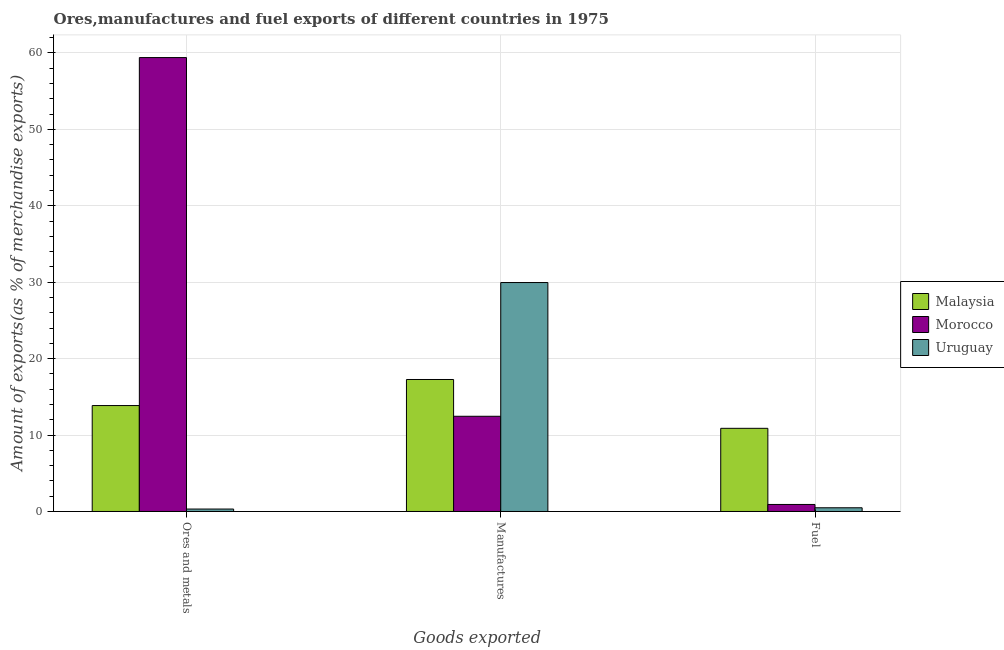How many different coloured bars are there?
Give a very brief answer. 3. How many groups of bars are there?
Keep it short and to the point. 3. Are the number of bars on each tick of the X-axis equal?
Keep it short and to the point. Yes. How many bars are there on the 1st tick from the right?
Provide a short and direct response. 3. What is the label of the 1st group of bars from the left?
Make the answer very short. Ores and metals. What is the percentage of manufactures exports in Morocco?
Your answer should be compact. 12.46. Across all countries, what is the maximum percentage of ores and metals exports?
Offer a terse response. 59.39. Across all countries, what is the minimum percentage of fuel exports?
Provide a short and direct response. 0.49. In which country was the percentage of ores and metals exports maximum?
Ensure brevity in your answer.  Morocco. In which country was the percentage of fuel exports minimum?
Offer a very short reply. Uruguay. What is the total percentage of manufactures exports in the graph?
Make the answer very short. 59.69. What is the difference between the percentage of ores and metals exports in Malaysia and that in Uruguay?
Keep it short and to the point. 13.54. What is the difference between the percentage of ores and metals exports in Malaysia and the percentage of manufactures exports in Uruguay?
Keep it short and to the point. -16.1. What is the average percentage of ores and metals exports per country?
Make the answer very short. 24.52. What is the difference between the percentage of fuel exports and percentage of manufactures exports in Uruguay?
Give a very brief answer. -29.47. In how many countries, is the percentage of fuel exports greater than 44 %?
Your response must be concise. 0. What is the ratio of the percentage of manufactures exports in Malaysia to that in Morocco?
Offer a terse response. 1.39. Is the difference between the percentage of fuel exports in Uruguay and Morocco greater than the difference between the percentage of manufactures exports in Uruguay and Morocco?
Your answer should be compact. No. What is the difference between the highest and the second highest percentage of manufactures exports?
Your answer should be very brief. 12.69. What is the difference between the highest and the lowest percentage of ores and metals exports?
Your answer should be very brief. 59.07. Is the sum of the percentage of ores and metals exports in Malaysia and Uruguay greater than the maximum percentage of fuel exports across all countries?
Your answer should be compact. Yes. What does the 2nd bar from the left in Ores and metals represents?
Make the answer very short. Morocco. What does the 1st bar from the right in Manufactures represents?
Offer a terse response. Uruguay. Is it the case that in every country, the sum of the percentage of ores and metals exports and percentage of manufactures exports is greater than the percentage of fuel exports?
Your answer should be very brief. Yes. Are all the bars in the graph horizontal?
Your answer should be very brief. No. Are the values on the major ticks of Y-axis written in scientific E-notation?
Your response must be concise. No. Does the graph contain grids?
Your response must be concise. Yes. How are the legend labels stacked?
Offer a very short reply. Vertical. What is the title of the graph?
Offer a terse response. Ores,manufactures and fuel exports of different countries in 1975. What is the label or title of the X-axis?
Provide a succinct answer. Goods exported. What is the label or title of the Y-axis?
Keep it short and to the point. Amount of exports(as % of merchandise exports). What is the Amount of exports(as % of merchandise exports) in Malaysia in Ores and metals?
Your answer should be very brief. 13.86. What is the Amount of exports(as % of merchandise exports) in Morocco in Ores and metals?
Your answer should be compact. 59.39. What is the Amount of exports(as % of merchandise exports) of Uruguay in Ores and metals?
Offer a terse response. 0.32. What is the Amount of exports(as % of merchandise exports) in Malaysia in Manufactures?
Make the answer very short. 17.27. What is the Amount of exports(as % of merchandise exports) in Morocco in Manufactures?
Offer a terse response. 12.46. What is the Amount of exports(as % of merchandise exports) in Uruguay in Manufactures?
Provide a succinct answer. 29.96. What is the Amount of exports(as % of merchandise exports) of Malaysia in Fuel?
Offer a terse response. 10.88. What is the Amount of exports(as % of merchandise exports) in Morocco in Fuel?
Provide a short and direct response. 0.92. What is the Amount of exports(as % of merchandise exports) of Uruguay in Fuel?
Offer a terse response. 0.49. Across all Goods exported, what is the maximum Amount of exports(as % of merchandise exports) of Malaysia?
Ensure brevity in your answer.  17.27. Across all Goods exported, what is the maximum Amount of exports(as % of merchandise exports) in Morocco?
Ensure brevity in your answer.  59.39. Across all Goods exported, what is the maximum Amount of exports(as % of merchandise exports) of Uruguay?
Offer a terse response. 29.96. Across all Goods exported, what is the minimum Amount of exports(as % of merchandise exports) of Malaysia?
Your response must be concise. 10.88. Across all Goods exported, what is the minimum Amount of exports(as % of merchandise exports) in Morocco?
Your answer should be compact. 0.92. Across all Goods exported, what is the minimum Amount of exports(as % of merchandise exports) of Uruguay?
Give a very brief answer. 0.32. What is the total Amount of exports(as % of merchandise exports) in Malaysia in the graph?
Ensure brevity in your answer.  42.01. What is the total Amount of exports(as % of merchandise exports) in Morocco in the graph?
Offer a very short reply. 72.77. What is the total Amount of exports(as % of merchandise exports) in Uruguay in the graph?
Make the answer very short. 30.76. What is the difference between the Amount of exports(as % of merchandise exports) of Malaysia in Ores and metals and that in Manufactures?
Provide a short and direct response. -3.41. What is the difference between the Amount of exports(as % of merchandise exports) in Morocco in Ores and metals and that in Manufactures?
Offer a terse response. 46.93. What is the difference between the Amount of exports(as % of merchandise exports) in Uruguay in Ores and metals and that in Manufactures?
Provide a short and direct response. -29.64. What is the difference between the Amount of exports(as % of merchandise exports) of Malaysia in Ores and metals and that in Fuel?
Make the answer very short. 2.98. What is the difference between the Amount of exports(as % of merchandise exports) in Morocco in Ores and metals and that in Fuel?
Your response must be concise. 58.47. What is the difference between the Amount of exports(as % of merchandise exports) of Uruguay in Ores and metals and that in Fuel?
Your answer should be compact. -0.17. What is the difference between the Amount of exports(as % of merchandise exports) in Malaysia in Manufactures and that in Fuel?
Provide a short and direct response. 6.39. What is the difference between the Amount of exports(as % of merchandise exports) in Morocco in Manufactures and that in Fuel?
Provide a short and direct response. 11.54. What is the difference between the Amount of exports(as % of merchandise exports) in Uruguay in Manufactures and that in Fuel?
Your answer should be compact. 29.47. What is the difference between the Amount of exports(as % of merchandise exports) in Malaysia in Ores and metals and the Amount of exports(as % of merchandise exports) in Morocco in Manufactures?
Provide a succinct answer. 1.4. What is the difference between the Amount of exports(as % of merchandise exports) of Malaysia in Ores and metals and the Amount of exports(as % of merchandise exports) of Uruguay in Manufactures?
Ensure brevity in your answer.  -16.1. What is the difference between the Amount of exports(as % of merchandise exports) of Morocco in Ores and metals and the Amount of exports(as % of merchandise exports) of Uruguay in Manufactures?
Provide a short and direct response. 29.44. What is the difference between the Amount of exports(as % of merchandise exports) of Malaysia in Ores and metals and the Amount of exports(as % of merchandise exports) of Morocco in Fuel?
Give a very brief answer. 12.94. What is the difference between the Amount of exports(as % of merchandise exports) in Malaysia in Ores and metals and the Amount of exports(as % of merchandise exports) in Uruguay in Fuel?
Make the answer very short. 13.37. What is the difference between the Amount of exports(as % of merchandise exports) in Morocco in Ores and metals and the Amount of exports(as % of merchandise exports) in Uruguay in Fuel?
Provide a succinct answer. 58.91. What is the difference between the Amount of exports(as % of merchandise exports) of Malaysia in Manufactures and the Amount of exports(as % of merchandise exports) of Morocco in Fuel?
Provide a succinct answer. 16.35. What is the difference between the Amount of exports(as % of merchandise exports) of Malaysia in Manufactures and the Amount of exports(as % of merchandise exports) of Uruguay in Fuel?
Ensure brevity in your answer.  16.78. What is the difference between the Amount of exports(as % of merchandise exports) in Morocco in Manufactures and the Amount of exports(as % of merchandise exports) in Uruguay in Fuel?
Make the answer very short. 11.97. What is the average Amount of exports(as % of merchandise exports) in Malaysia per Goods exported?
Provide a succinct answer. 14. What is the average Amount of exports(as % of merchandise exports) in Morocco per Goods exported?
Ensure brevity in your answer.  24.26. What is the average Amount of exports(as % of merchandise exports) in Uruguay per Goods exported?
Your answer should be compact. 10.25. What is the difference between the Amount of exports(as % of merchandise exports) of Malaysia and Amount of exports(as % of merchandise exports) of Morocco in Ores and metals?
Your answer should be compact. -45.53. What is the difference between the Amount of exports(as % of merchandise exports) in Malaysia and Amount of exports(as % of merchandise exports) in Uruguay in Ores and metals?
Your answer should be compact. 13.54. What is the difference between the Amount of exports(as % of merchandise exports) of Morocco and Amount of exports(as % of merchandise exports) of Uruguay in Ores and metals?
Provide a succinct answer. 59.07. What is the difference between the Amount of exports(as % of merchandise exports) of Malaysia and Amount of exports(as % of merchandise exports) of Morocco in Manufactures?
Your response must be concise. 4.81. What is the difference between the Amount of exports(as % of merchandise exports) of Malaysia and Amount of exports(as % of merchandise exports) of Uruguay in Manufactures?
Provide a succinct answer. -12.69. What is the difference between the Amount of exports(as % of merchandise exports) of Morocco and Amount of exports(as % of merchandise exports) of Uruguay in Manufactures?
Your response must be concise. -17.5. What is the difference between the Amount of exports(as % of merchandise exports) of Malaysia and Amount of exports(as % of merchandise exports) of Morocco in Fuel?
Provide a succinct answer. 9.96. What is the difference between the Amount of exports(as % of merchandise exports) in Malaysia and Amount of exports(as % of merchandise exports) in Uruguay in Fuel?
Ensure brevity in your answer.  10.39. What is the difference between the Amount of exports(as % of merchandise exports) of Morocco and Amount of exports(as % of merchandise exports) of Uruguay in Fuel?
Your answer should be very brief. 0.43. What is the ratio of the Amount of exports(as % of merchandise exports) of Malaysia in Ores and metals to that in Manufactures?
Give a very brief answer. 0.8. What is the ratio of the Amount of exports(as % of merchandise exports) of Morocco in Ores and metals to that in Manufactures?
Make the answer very short. 4.77. What is the ratio of the Amount of exports(as % of merchandise exports) in Uruguay in Ores and metals to that in Manufactures?
Your answer should be compact. 0.01. What is the ratio of the Amount of exports(as % of merchandise exports) in Malaysia in Ores and metals to that in Fuel?
Keep it short and to the point. 1.27. What is the ratio of the Amount of exports(as % of merchandise exports) of Morocco in Ores and metals to that in Fuel?
Make the answer very short. 64.66. What is the ratio of the Amount of exports(as % of merchandise exports) in Uruguay in Ores and metals to that in Fuel?
Your answer should be compact. 0.66. What is the ratio of the Amount of exports(as % of merchandise exports) of Malaysia in Manufactures to that in Fuel?
Provide a short and direct response. 1.59. What is the ratio of the Amount of exports(as % of merchandise exports) of Morocco in Manufactures to that in Fuel?
Offer a terse response. 13.56. What is the ratio of the Amount of exports(as % of merchandise exports) in Uruguay in Manufactures to that in Fuel?
Give a very brief answer. 61.58. What is the difference between the highest and the second highest Amount of exports(as % of merchandise exports) of Malaysia?
Ensure brevity in your answer.  3.41. What is the difference between the highest and the second highest Amount of exports(as % of merchandise exports) of Morocco?
Offer a very short reply. 46.93. What is the difference between the highest and the second highest Amount of exports(as % of merchandise exports) in Uruguay?
Offer a terse response. 29.47. What is the difference between the highest and the lowest Amount of exports(as % of merchandise exports) of Malaysia?
Keep it short and to the point. 6.39. What is the difference between the highest and the lowest Amount of exports(as % of merchandise exports) in Morocco?
Keep it short and to the point. 58.47. What is the difference between the highest and the lowest Amount of exports(as % of merchandise exports) of Uruguay?
Offer a terse response. 29.64. 